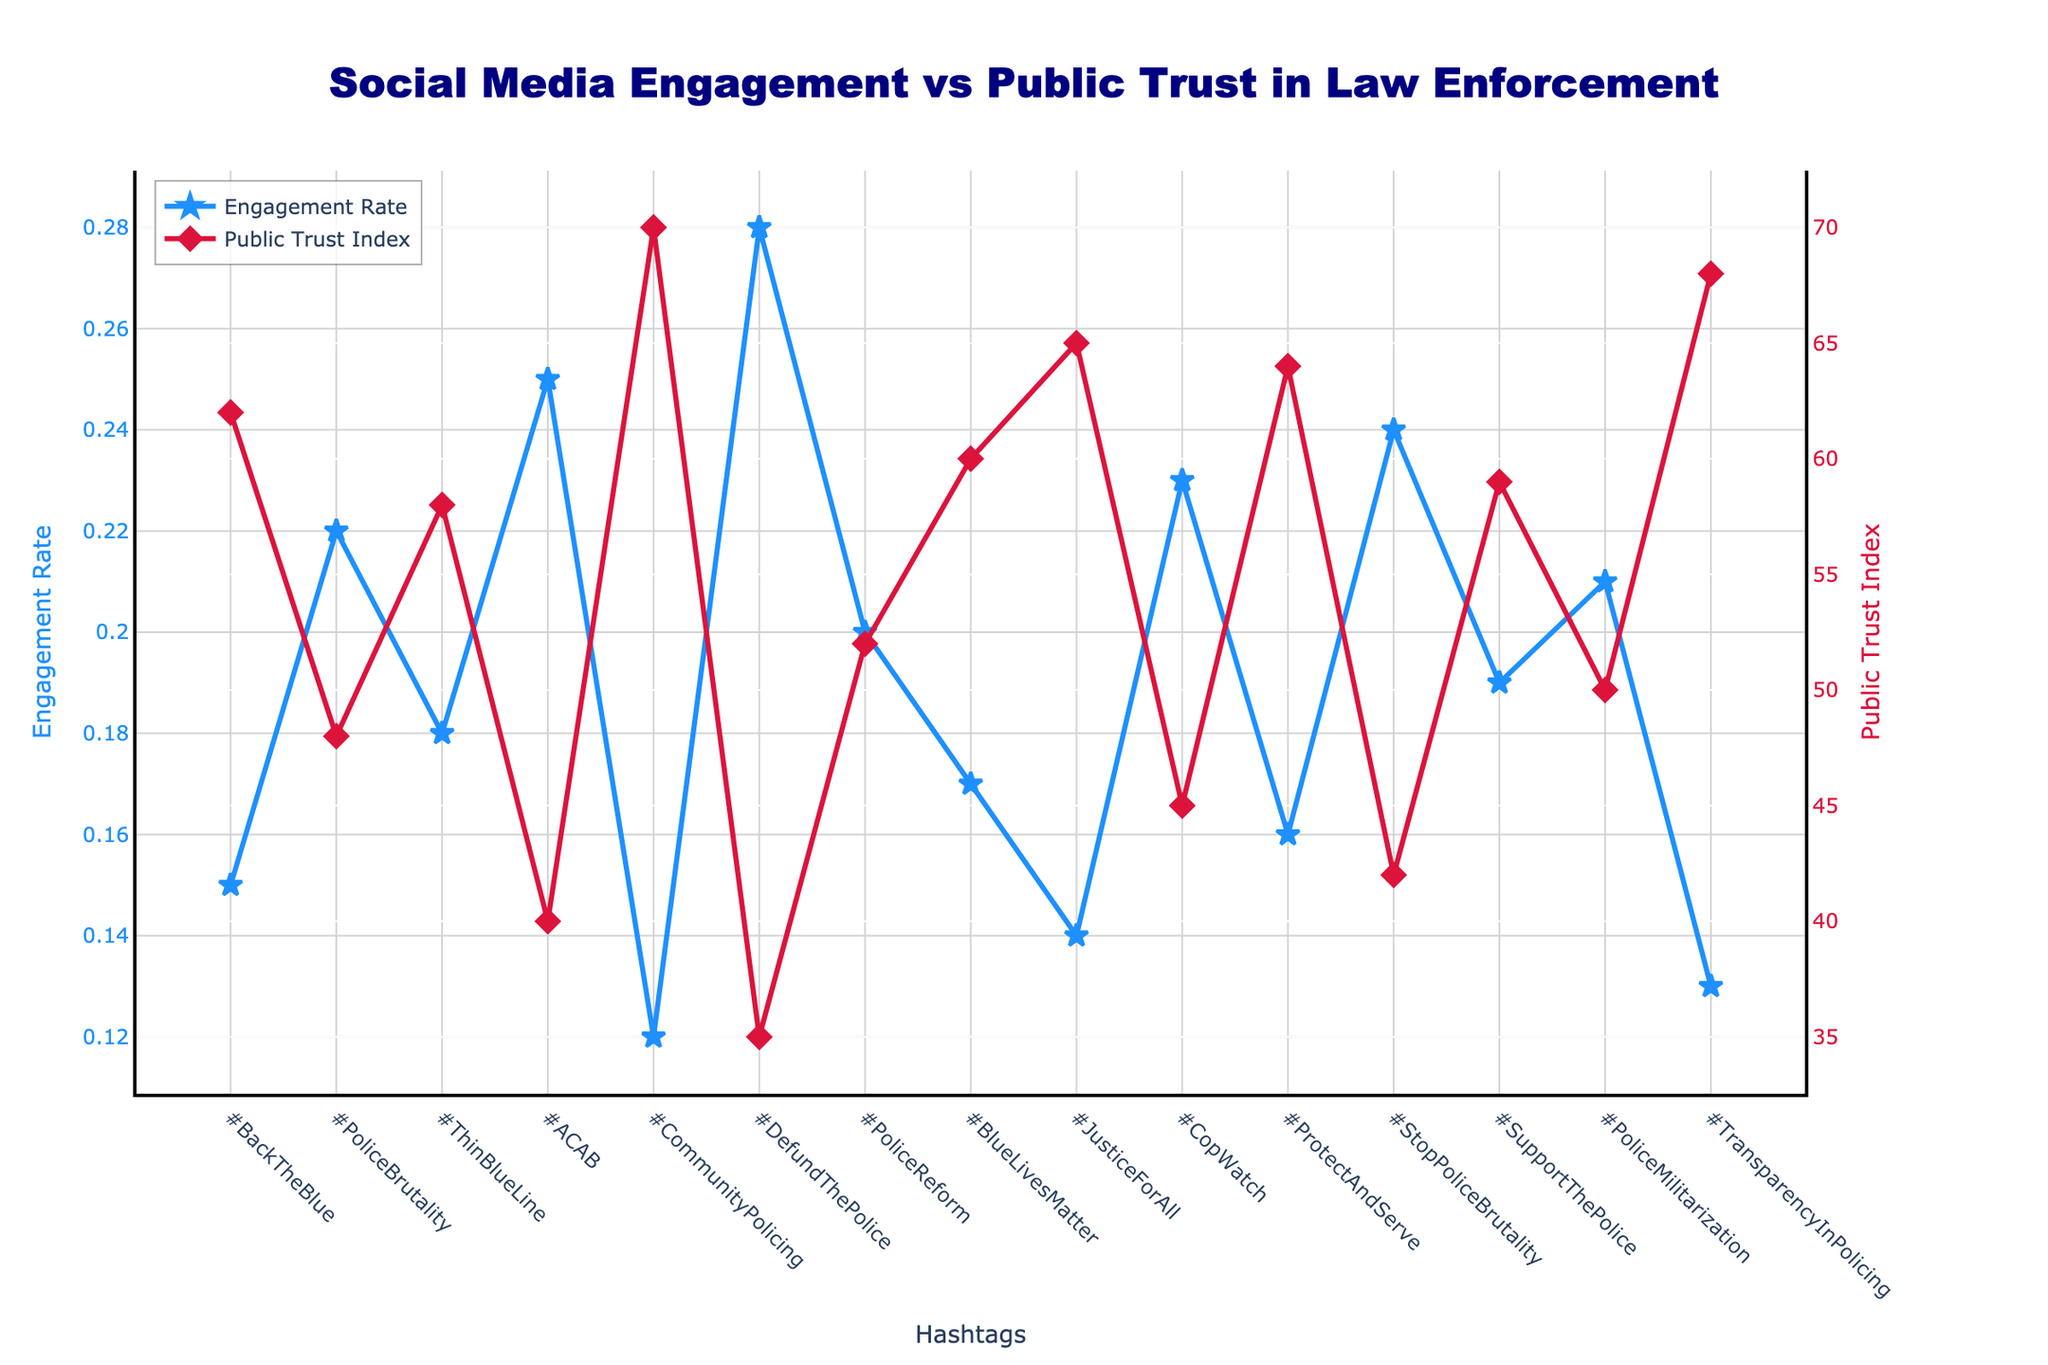What is the average public trust index for hashtags with an engagement rate above 0.2? First, identify the hashtags with an engagement rate above 0.2: "#PoliceBrutality", "#ACAB", "#DefundThePolice", "#CopWatch", and "#StopPoliceBrutality". Corresponding public trust values are 48, 40, 35, 45, and 42. Sum these values: 48 + 40 + 35 + 45 + 42 = 210. The average is 210 / 5 = 42
Answer: 42 Which hashtag has the highest engagement rate, and what is its public trust index? The hashtag with the highest engagement rate is "#DefundThePolice" with an engagement rate of 0.28. Its public trust index is 35
Answer: #DefundThePolice, 35 Between "#BackTheBlue" and "#ProtectAndServe", which one has a higher public trust index and by how much? "#BackTheBlue" has a public trust index of 62, and "#ProtectAndServe" has 64. The difference is 64 - 62 = 2
Answer: #ProtectAndServe, 2 Which hashtag shows the largest difference between engagement rate and public trust index? Calculate the difference for each hashtag: 
"#BackTheBlue" (0.15, 62): 62 - 15 = 47 
"#PoliceBrutality" (0.22, 48): 48 - 22 = 26
"#ThinBlueLine" (0.18, 58): 58 - 18 = 40
"#ACAB" (0.25, 40): 40 - 25 = 15
"#CommunityPolicing" (0.12, 70): 70 - 12 = 58
"#DefundThePolice" (0.28, 35): 35 - 28 = 7
"#PoliceReform" (0.20, 52): 52 - 20 = 32
"#BlueLivesMatter" (0.17, 60): 60 - 17 = 43
"#JusticeForAll" (0.14, 65): 65 - 14 = 51
"#CopWatch" (0.23, 45): 45 - 23 = 22
"#ProtectAndServe" (0.16, 64): 64 - 16 = 48
"#StopPoliceBrutality" (0.24, 42): 42 - 24 = 18
"#SupportThePolice" (0.19, 59): 59 - 19 = 40
"#PoliceMilitarization" (0.21, 50): 50 - 21 = 29
"#TransparencyInPolicing" (0.13, 68): 68 - 13 = 55 
The largest difference is "#CommunityPolicing" with 58
Answer: #CommunityPolicing, 58 What is the sum of the public trust indices for hashtags with an engagement rate below 0.15? Identify hashtags with an engagement rate below 0.15: "#CommunityPolicing", "#JusticeForAll", "#TransparencyInPolicing". Corresponding public trust values are 70, 65, and 68. Sum these values: 70 + 65 + 68 = 203
Answer: 203 Which hashtag shows the lowest public trust index and what is its engagement rate? The hashtag with the lowest public trust index is "#DefundThePolice" with an index of 35, and its engagement rate is 0.28
Answer: #DefundThePolice, 0.28 